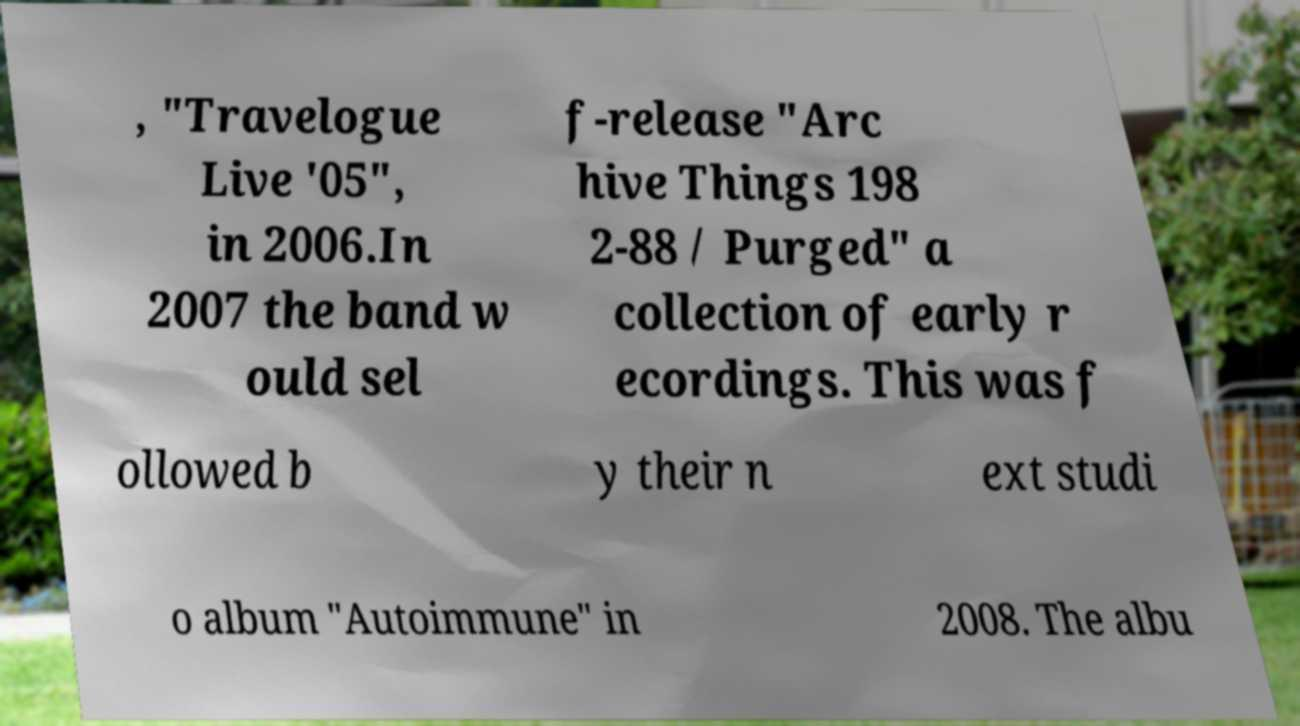Please read and relay the text visible in this image. What does it say? , "Travelogue Live '05", in 2006.In 2007 the band w ould sel f-release "Arc hive Things 198 2-88 / Purged" a collection of early r ecordings. This was f ollowed b y their n ext studi o album "Autoimmune" in 2008. The albu 